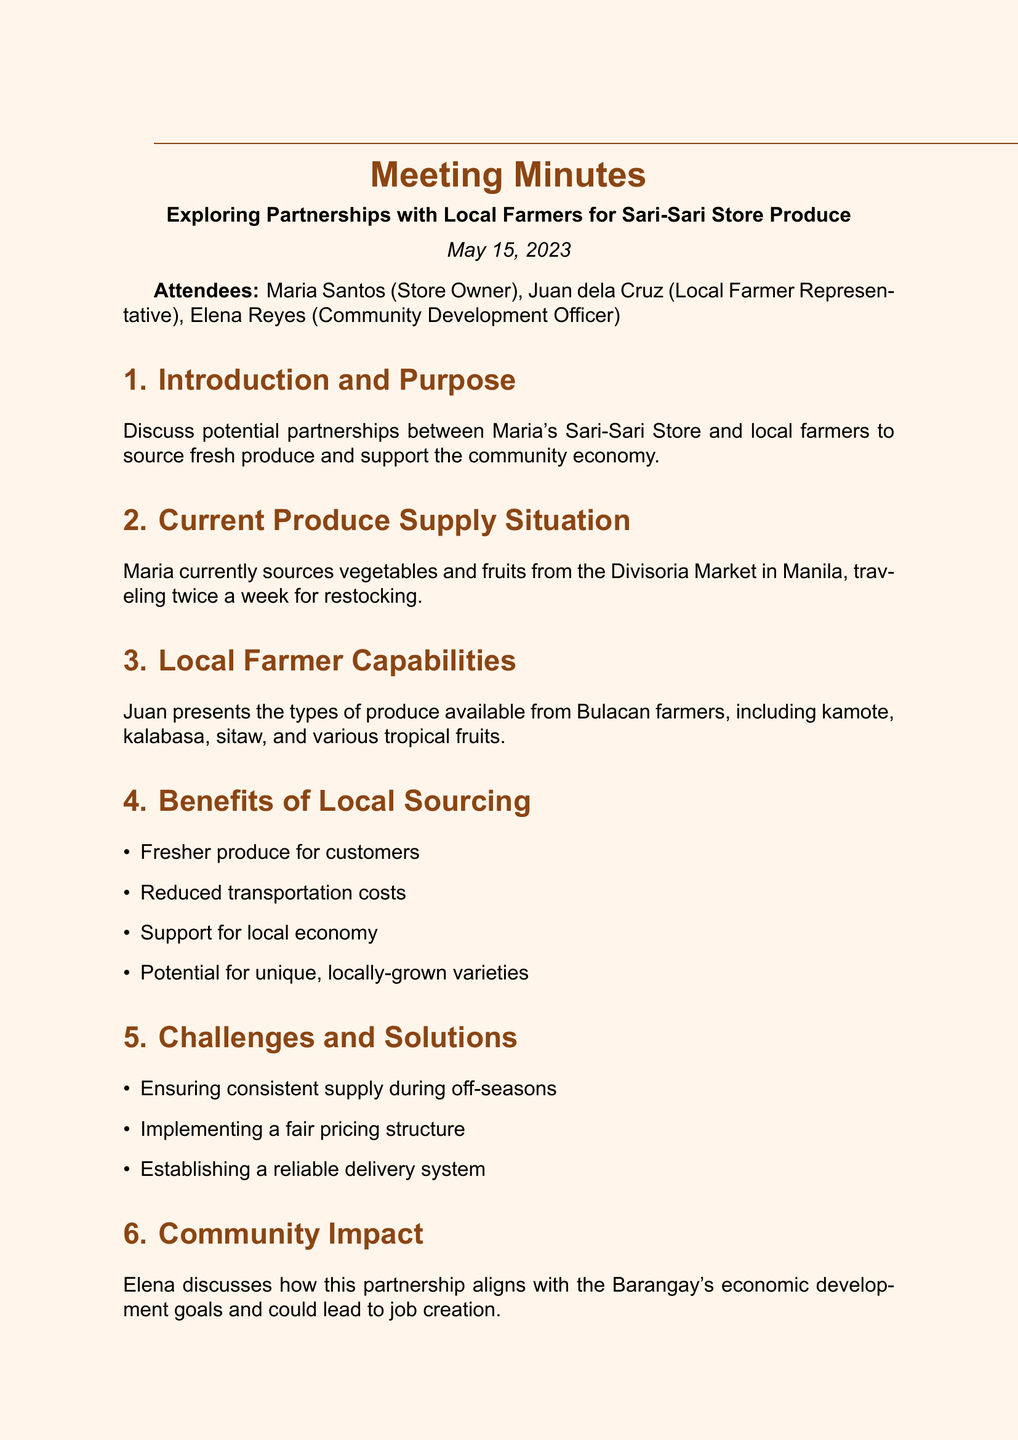What is the meeting date? The meeting date is explicitly stated in the document under the date section.
Answer: May 15, 2023 Who is the store owner? The store owner's name is mentioned in the attendees list at the beginning of the document.
Answer: Maria Santos What types of produce are mentioned from Bulacan farmers? The document lists types of produce in the Local Farmer Capabilities section, providing specific produce names.
Answer: Kamote, kalabasa, sitaw, and various tropical fruits What is one benefit of local sourcing? The document lists benefits in the Benefits of Local Sourcing section, any listed benefit can be an answer.
Answer: Fresher produce for customers What challenge is highlighted in the meeting? The document discusses various challenges in the Challenges and Solutions section, providing a specific example.
Answer: Ensuring consistent supply during off-seasons How many attendees were at the meeting? The number of attendees can be counted from the attendees list at the beginning of the document.
Answer: Three What is the next step for Maria? The next step for Maria is detailed in the Next Steps section of the document.
Answer: Visit local farms next week What is the aim of the partnership discussed? The aim of the partnership is stated in the Introduction and Purpose section, summarizing the goal.
Answer: Source fresh produce and support the community economy 